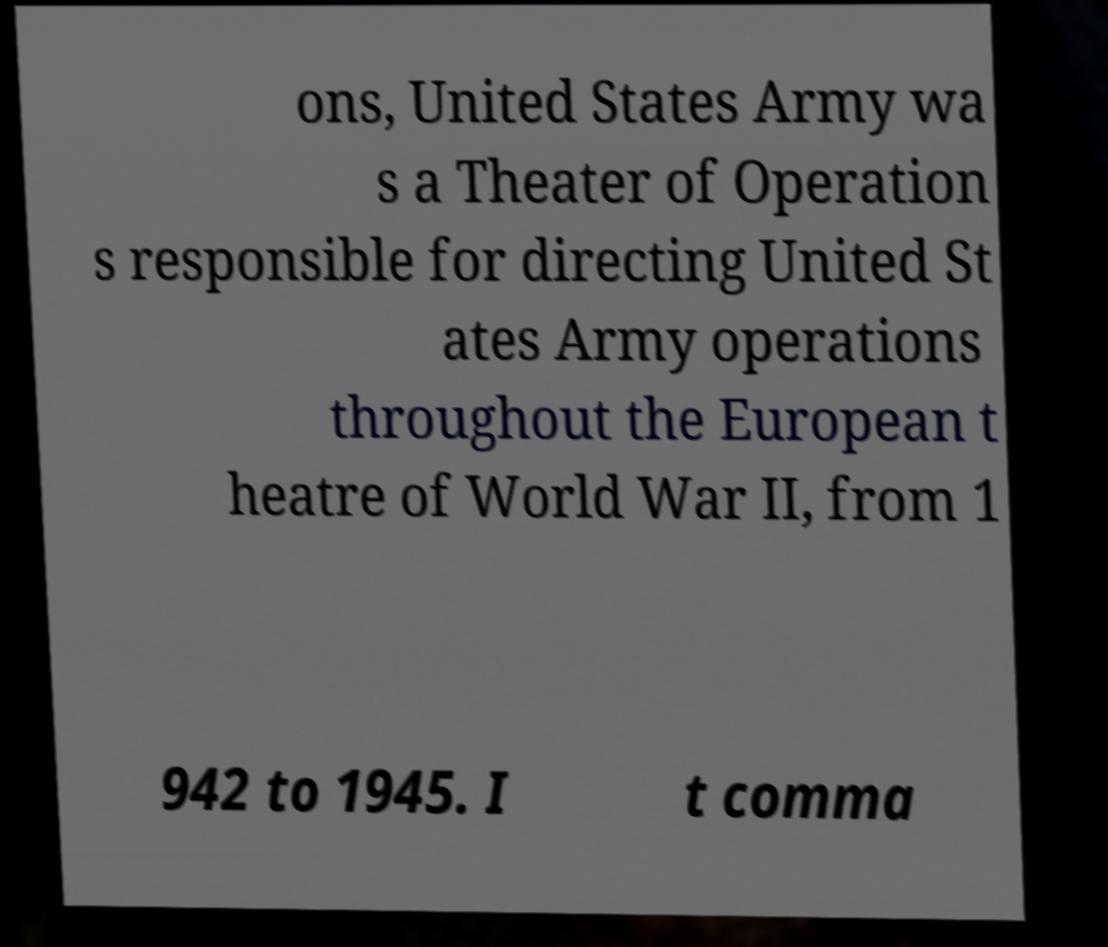Please identify and transcribe the text found in this image. ons, United States Army wa s a Theater of Operation s responsible for directing United St ates Army operations throughout the European t heatre of World War II, from 1 942 to 1945. I t comma 